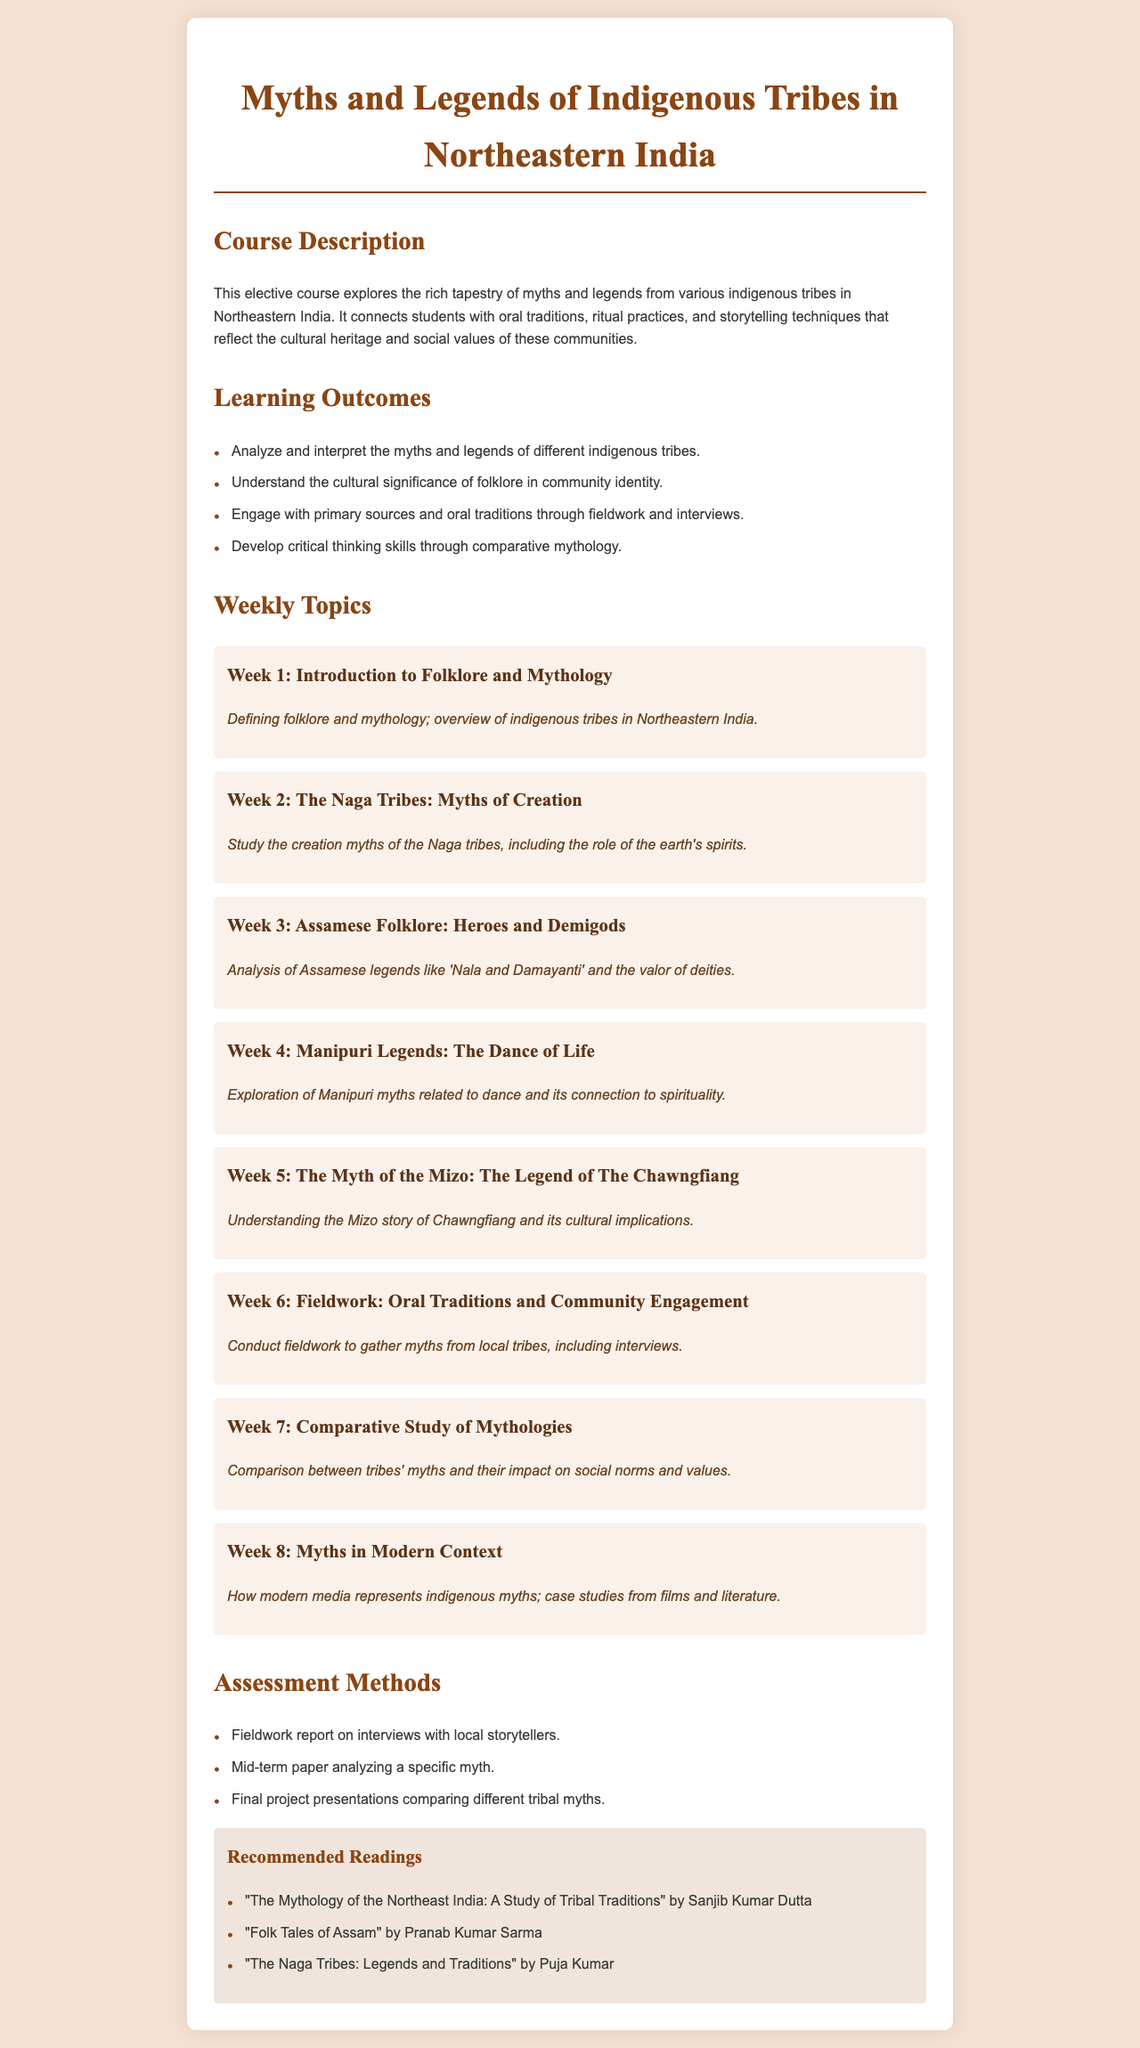What is the title of the course? The title of the course is mentioned at the top of the document.
Answer: Myths and Legends of Indigenous Tribes in Northeastern India How many weeks are there in the course? The document outlines the weekly topics, which indicates the number of weeks.
Answer: 8 What is one learning outcome of the course? The document lists several learning outcomes for the course.
Answer: Analyze and interpret the myths and legends of different indigenous tribes Which tribe's creation myths are studied in Week 2? The week topic specifies which tribe's myths are covered for that week.
Answer: Naga Tribes What type of assessment involves fieldwork? The assessment methods section specifies various assessments that incorporate fieldwork.
Answer: Fieldwork report on interviews with local storytellers Name one recommended reading. The document provides a list of recommended readings for further study.
Answer: The Mythology of the Northeast India: A Study of Tribal Traditions What is the focus of Week 4? The focus specifies the subject studied during that week within the course.
Answer: Myths related to dance and its connection to spirituality What is the primary focus of Week 8? The week topic summarizes the focus for that particular week.
Answer: How modern media represents indigenous myths 